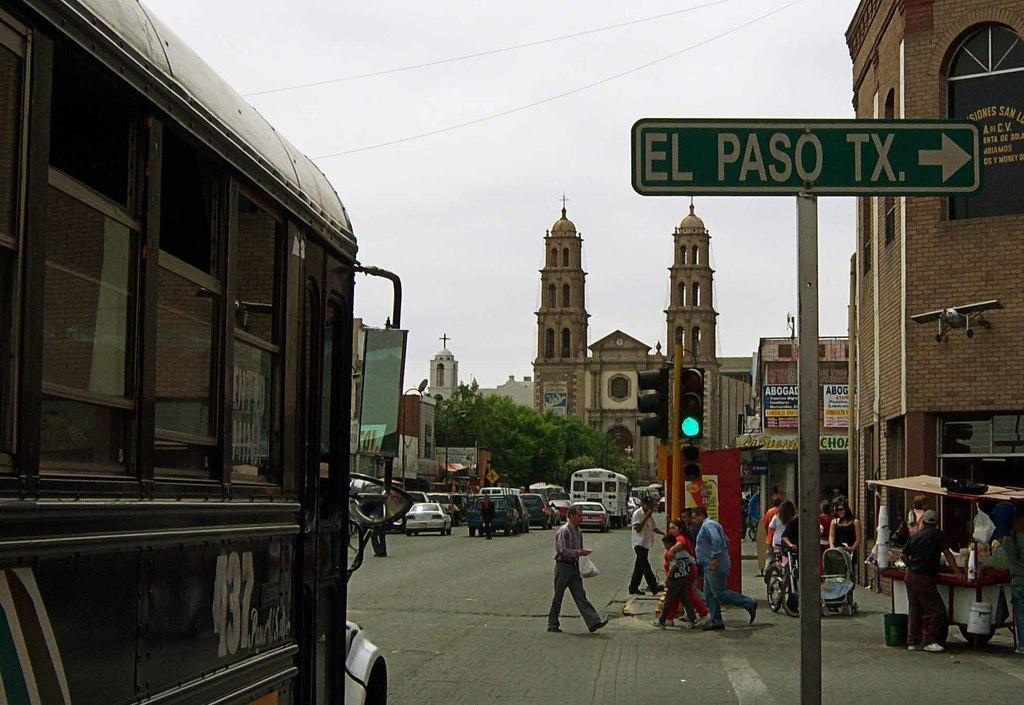How would you summarize this image in a sentence or two? This picture shows a few buildings and we see trees and we see few people walking and a name board to the pole and a man walking and holding a carry bag in his hand and we see traffic signal lights and few advertisement hoardings on the wall and we see a cart on the side and a cloudy sky. 